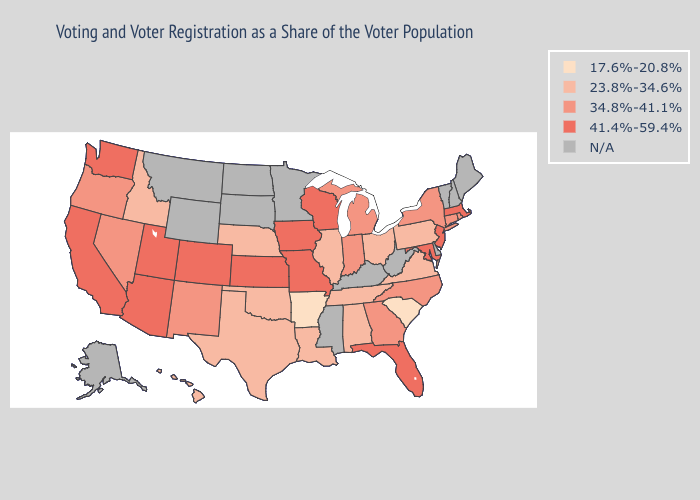Among the states that border Kansas , which have the highest value?
Give a very brief answer. Colorado, Missouri. Does Arkansas have the lowest value in the USA?
Concise answer only. Yes. What is the value of Washington?
Give a very brief answer. 41.4%-59.4%. What is the value of Connecticut?
Short answer required. 34.8%-41.1%. Name the states that have a value in the range 17.6%-20.8%?
Concise answer only. Arkansas, South Carolina. Is the legend a continuous bar?
Concise answer only. No. Which states have the lowest value in the USA?
Write a very short answer. Arkansas, South Carolina. What is the value of Texas?
Concise answer only. 23.8%-34.6%. Does Connecticut have the lowest value in the Northeast?
Answer briefly. No. Name the states that have a value in the range 17.6%-20.8%?
Keep it brief. Arkansas, South Carolina. Among the states that border Indiana , does Ohio have the highest value?
Be succinct. No. What is the value of Pennsylvania?
Give a very brief answer. 23.8%-34.6%. 